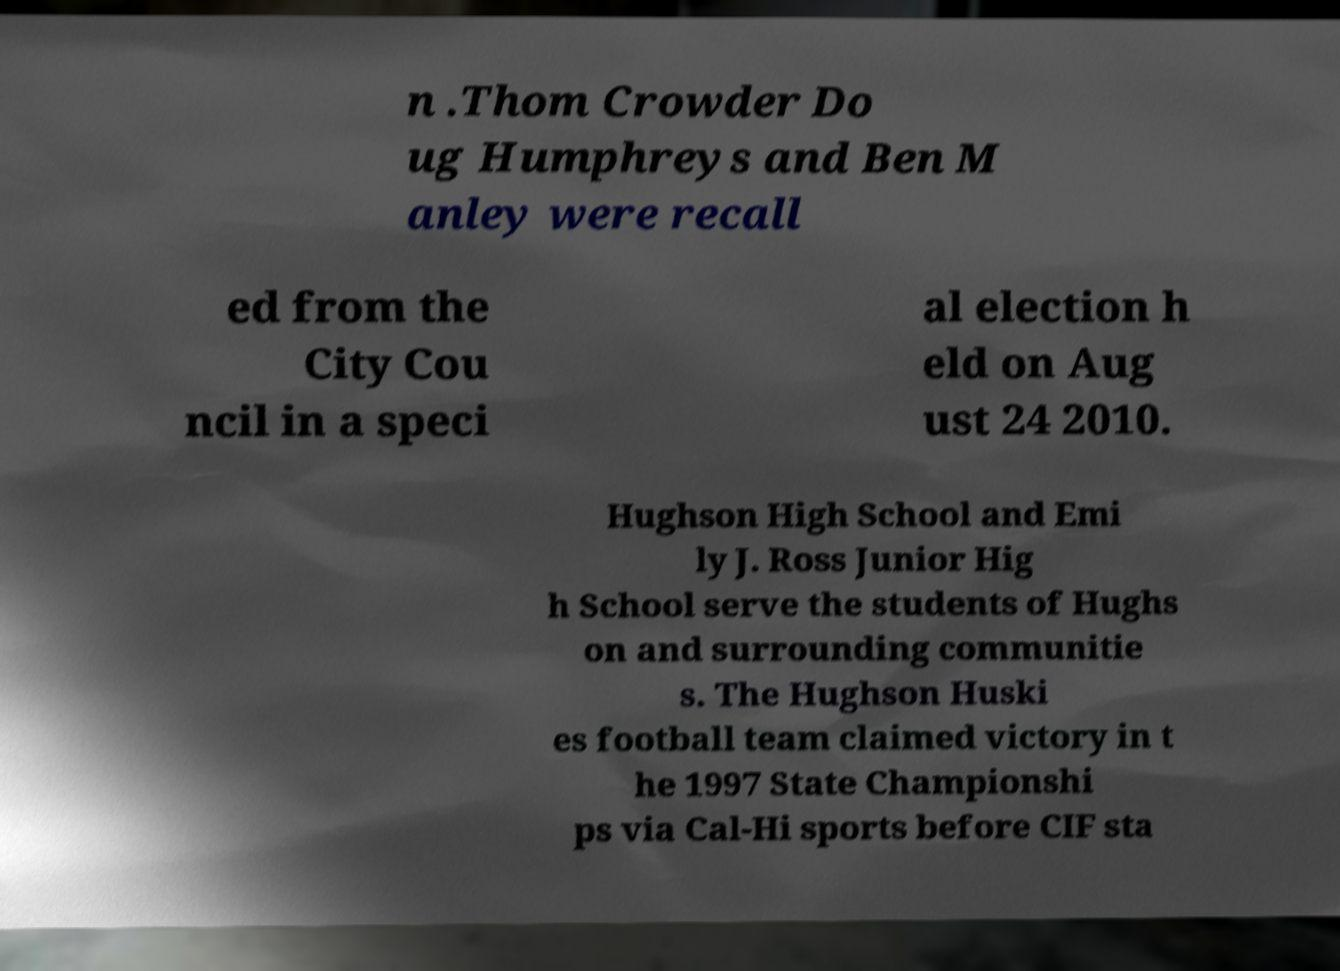Can you read and provide the text displayed in the image?This photo seems to have some interesting text. Can you extract and type it out for me? n .Thom Crowder Do ug Humphreys and Ben M anley were recall ed from the City Cou ncil in a speci al election h eld on Aug ust 24 2010. Hughson High School and Emi ly J. Ross Junior Hig h School serve the students of Hughs on and surrounding communitie s. The Hughson Huski es football team claimed victory in t he 1997 State Championshi ps via Cal-Hi sports before CIF sta 